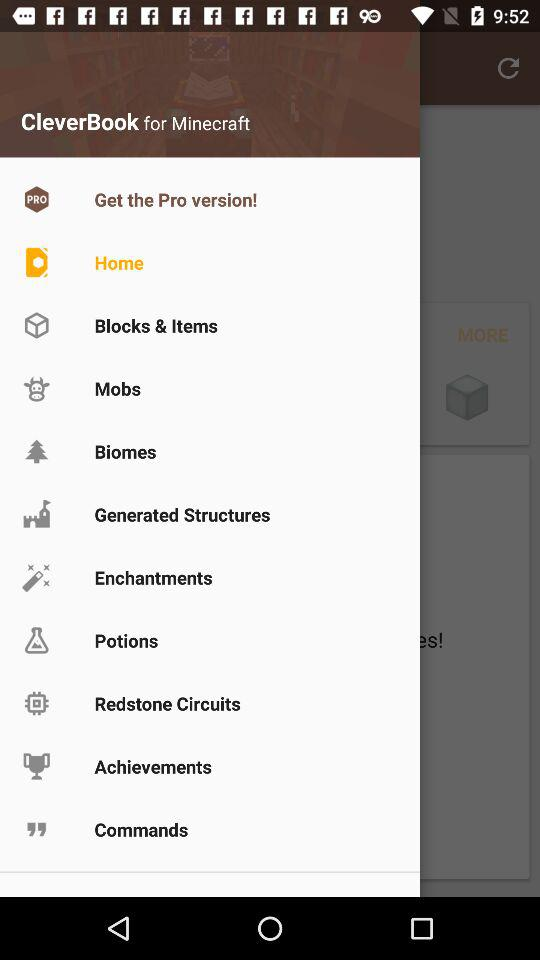What's the selected menu item? The selected menu item is "Home". 